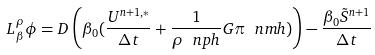<formula> <loc_0><loc_0><loc_500><loc_500>L _ { \beta } ^ { \rho } \phi = D \left ( \beta _ { 0 } ( \frac { U ^ { n + 1 , * } } { \Delta t } + \frac { 1 } { \rho ^ { \ } n p h } G \pi ^ { \ } n m h ) \right ) - \frac { \beta _ { 0 } \tilde { S } ^ { n + 1 } } { \Delta t }</formula> 